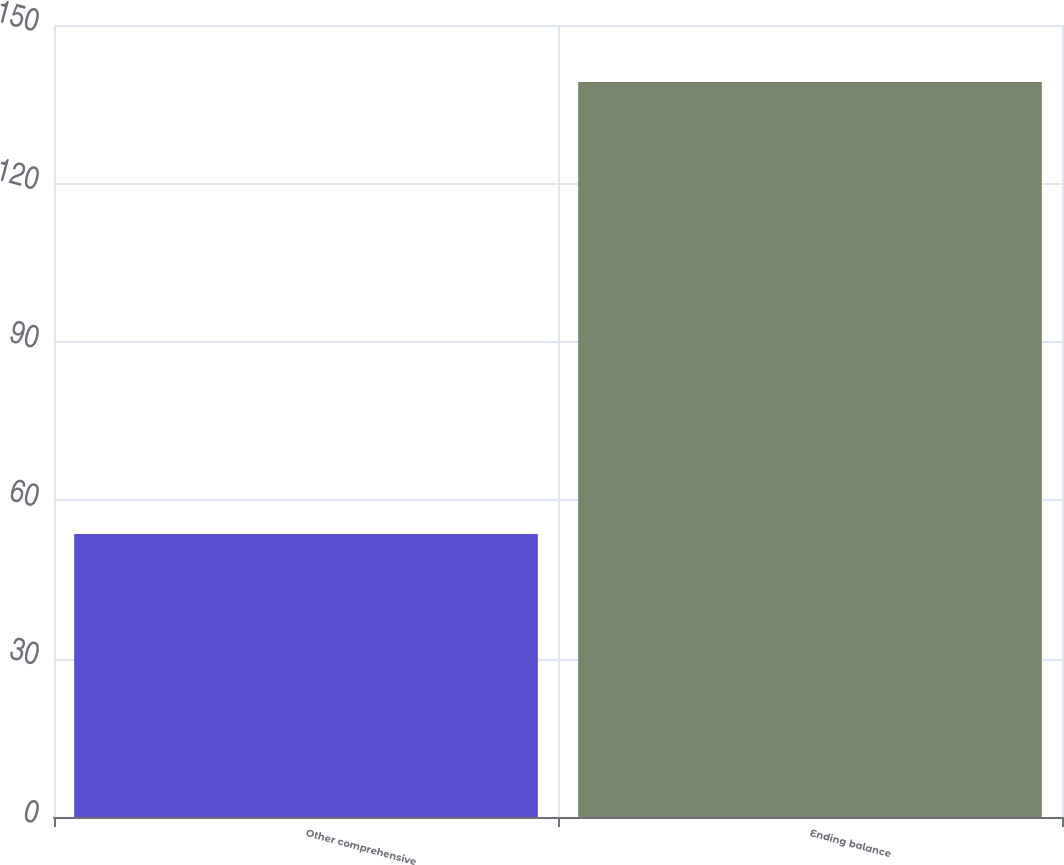<chart> <loc_0><loc_0><loc_500><loc_500><bar_chart><fcel>Other comprehensive<fcel>Ending balance<nl><fcel>53.6<fcel>139.2<nl></chart> 